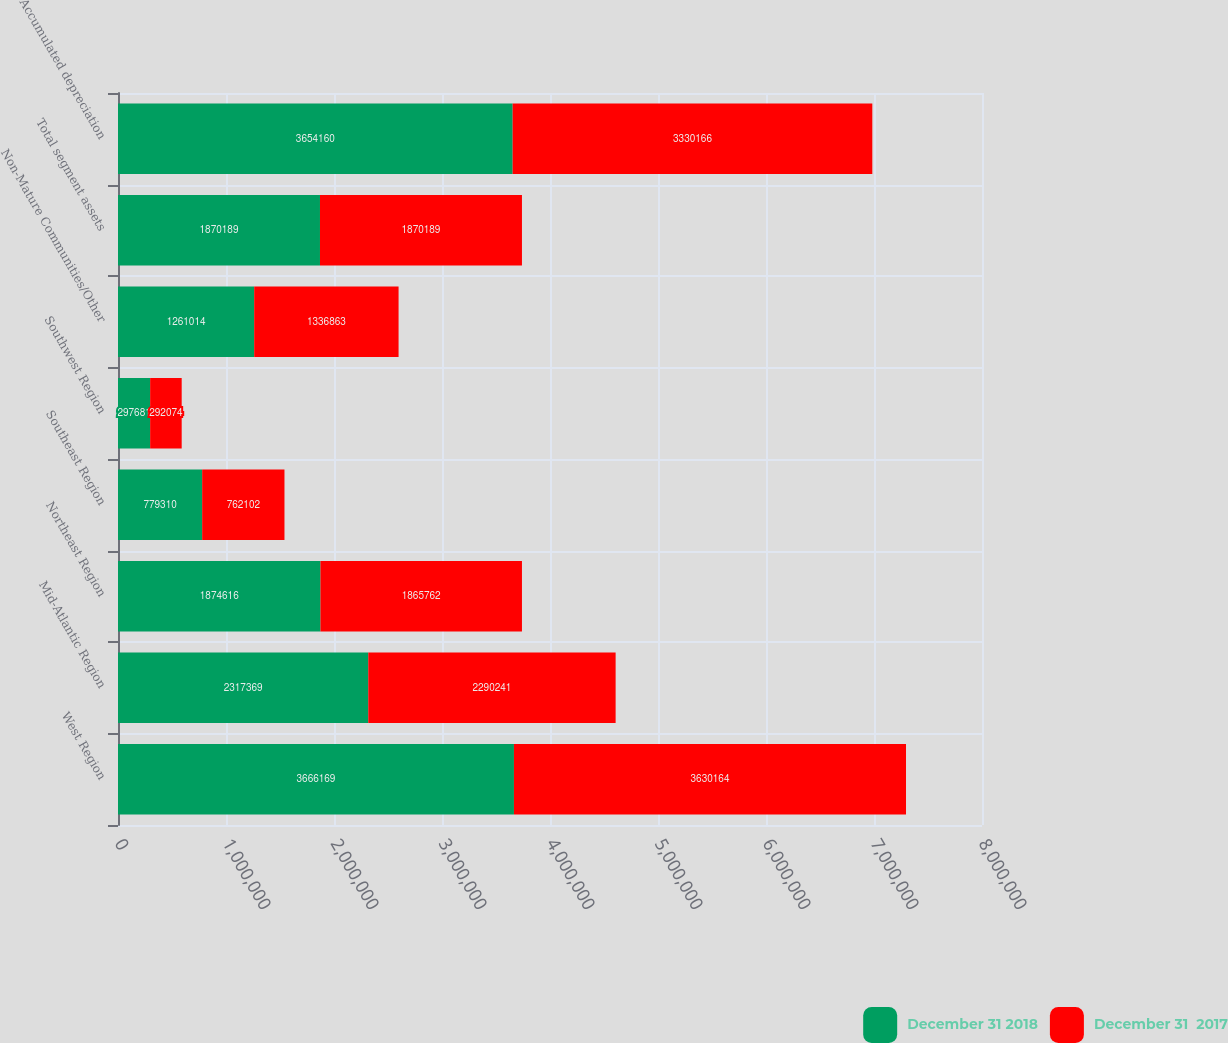<chart> <loc_0><loc_0><loc_500><loc_500><stacked_bar_chart><ecel><fcel>West Region<fcel>Mid-Atlantic Region<fcel>Northeast Region<fcel>Southeast Region<fcel>Southwest Region<fcel>Non-Mature Communities/Other<fcel>Total segment assets<fcel>Accumulated depreciation<nl><fcel>December 31 2018<fcel>3.66617e+06<fcel>2.31737e+06<fcel>1.87462e+06<fcel>779310<fcel>297681<fcel>1.26101e+06<fcel>1.87019e+06<fcel>3.65416e+06<nl><fcel>December 31  2017<fcel>3.63016e+06<fcel>2.29024e+06<fcel>1.86576e+06<fcel>762102<fcel>292074<fcel>1.33686e+06<fcel>1.87019e+06<fcel>3.33017e+06<nl></chart> 